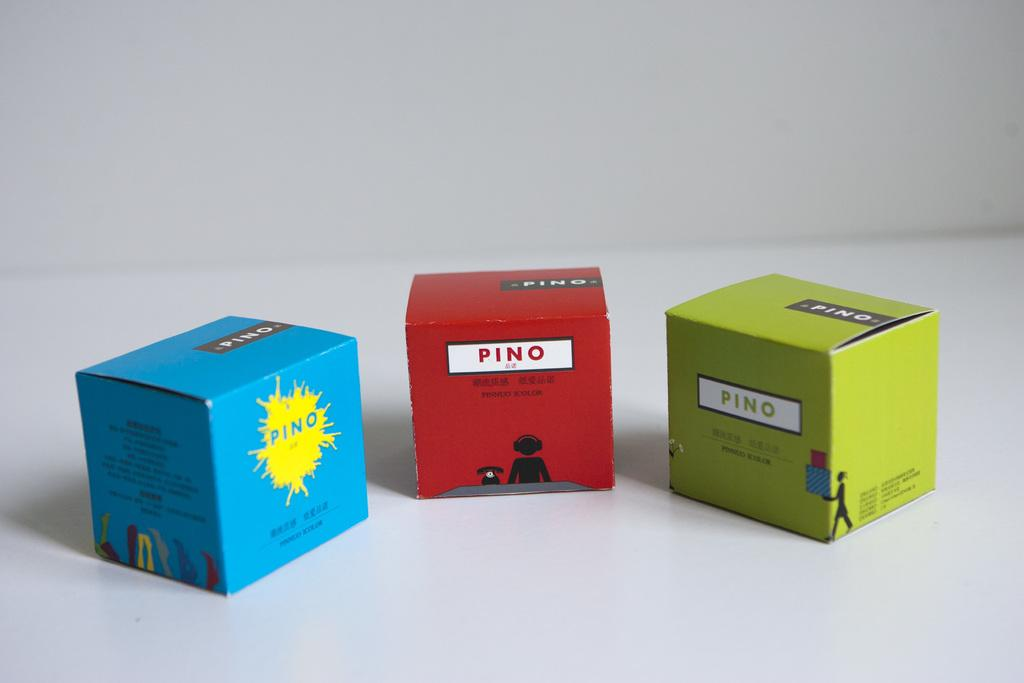<image>
Describe the image concisely. Boxes with Pino on the front are in three different colors. 